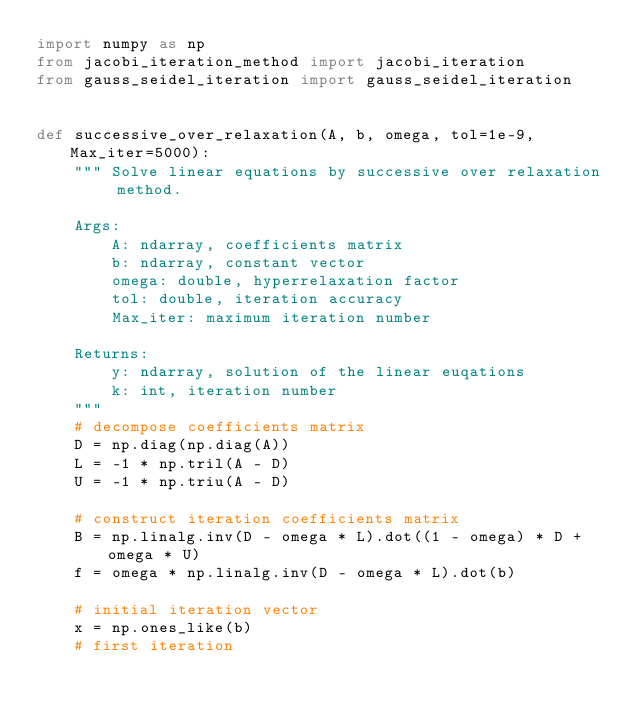<code> <loc_0><loc_0><loc_500><loc_500><_Python_>import numpy as np
from jacobi_iteration_method import jacobi_iteration
from gauss_seidel_iteration import gauss_seidel_iteration


def successive_over_relaxation(A, b, omega, tol=1e-9, Max_iter=5000):
    """ Solve linear equations by successive over relaxation method.

    Args:
        A: ndarray, coefficients matrix
        b: ndarray, constant vector
        omega: double, hyperrelaxation factor
        tol: double, iteration accuracy
        Max_iter: maximum iteration number

    Returns:
        y: ndarray, solution of the linear euqations
        k: int, iteration number
    """
    # decompose coefficients matrix
    D = np.diag(np.diag(A))
    L = -1 * np.tril(A - D)
    U = -1 * np.triu(A - D)

    # construct iteration coefficients matrix
    B = np.linalg.inv(D - omega * L).dot((1 - omega) * D + omega * U)
    f = omega * np.linalg.inv(D - omega * L).dot(b)

    # initial iteration vector
    x = np.ones_like(b)
    # first iteration</code> 